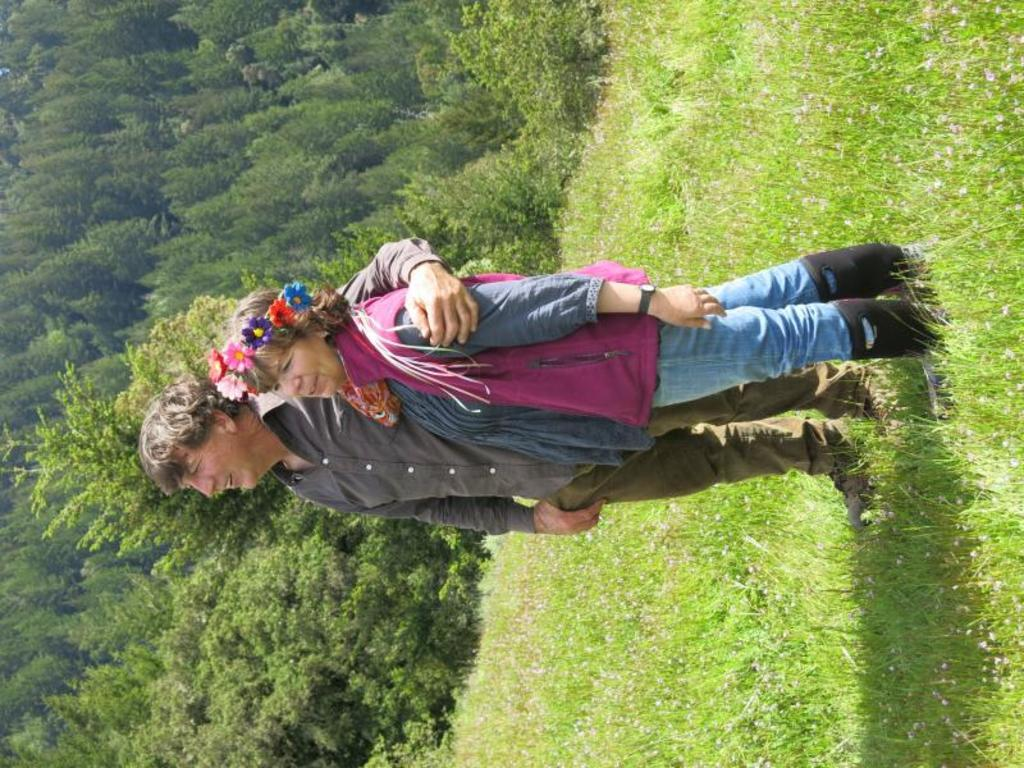What is the gender of the person in the image? There is a man in the image. What is the man wearing? The man is wearing a grey dress. Who is standing beside the man? There is a woman standing beside the man. What is the setting of the image? The man and woman are standing on grassland. What can be seen in the background of the image? There are trees in the background of the image. How is the image oriented? The image is in a vertical orientation. What type of needle is being used by the man in the image? There is no needle present in the image. What is the title of the image? The image does not have a title. 